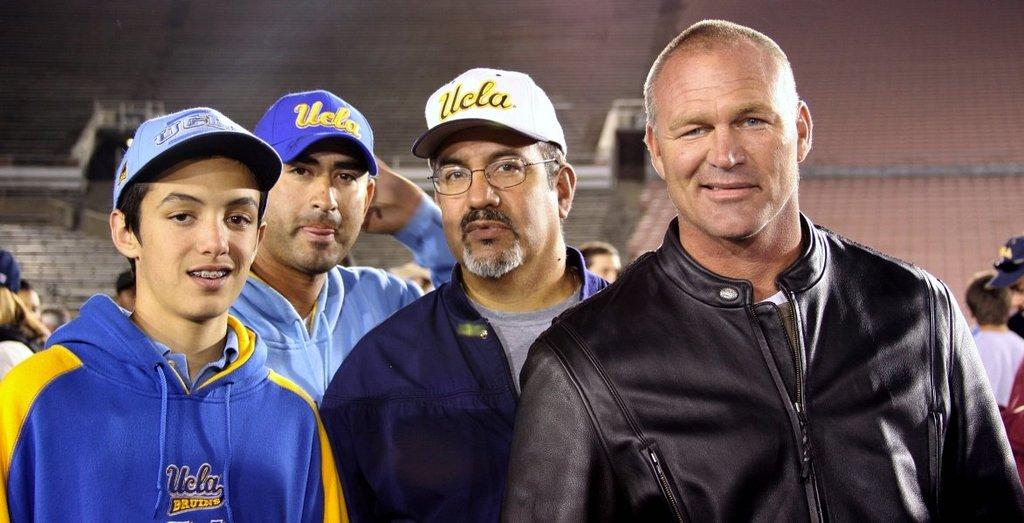Who or what can be seen in the image? There are people in the image. What are some of the people wearing? Some of the people are wearing caps. What can be seen in the background of the image? There is a wall in the background of the image. Are there any other people visible in the image? Yes, there are other people visible in the background. What hobbies do the people in the image have? There is no information about the hobbies of the people in the image. Can you tell me what the mother of the person in the image is doing? There is no information about a mother or any specific person in the image. 